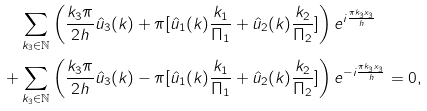<formula> <loc_0><loc_0><loc_500><loc_500>& \sum _ { k _ { 3 } \in \mathbb { N } } \left ( \frac { k _ { 3 } \pi } { 2 h } \hat { u } _ { 3 } ( k ) + \pi [ \hat { u } _ { 1 } ( k ) \frac { k _ { 1 } } { \Pi _ { 1 } } + \hat { u } _ { 2 } ( k ) \frac { k _ { 2 } } { \Pi _ { 2 } } ] \right ) e ^ { i \frac { \pi k _ { 3 } x _ { 3 } } { h } } \\ + & \sum _ { k _ { 3 } \in \mathbb { N } } \left ( \frac { k _ { 3 } \pi } { 2 h } \hat { u } _ { 3 } ( k ) - \pi [ \hat { u } _ { 1 } ( k ) \frac { k _ { 1 } } { \Pi _ { 1 } } + \hat { u } _ { 2 } ( k ) \frac { k _ { 2 } } { \Pi _ { 2 } } ] \right ) e ^ { - i \frac { \pi k _ { 3 } x _ { 3 } } { h } } = 0 ,</formula> 